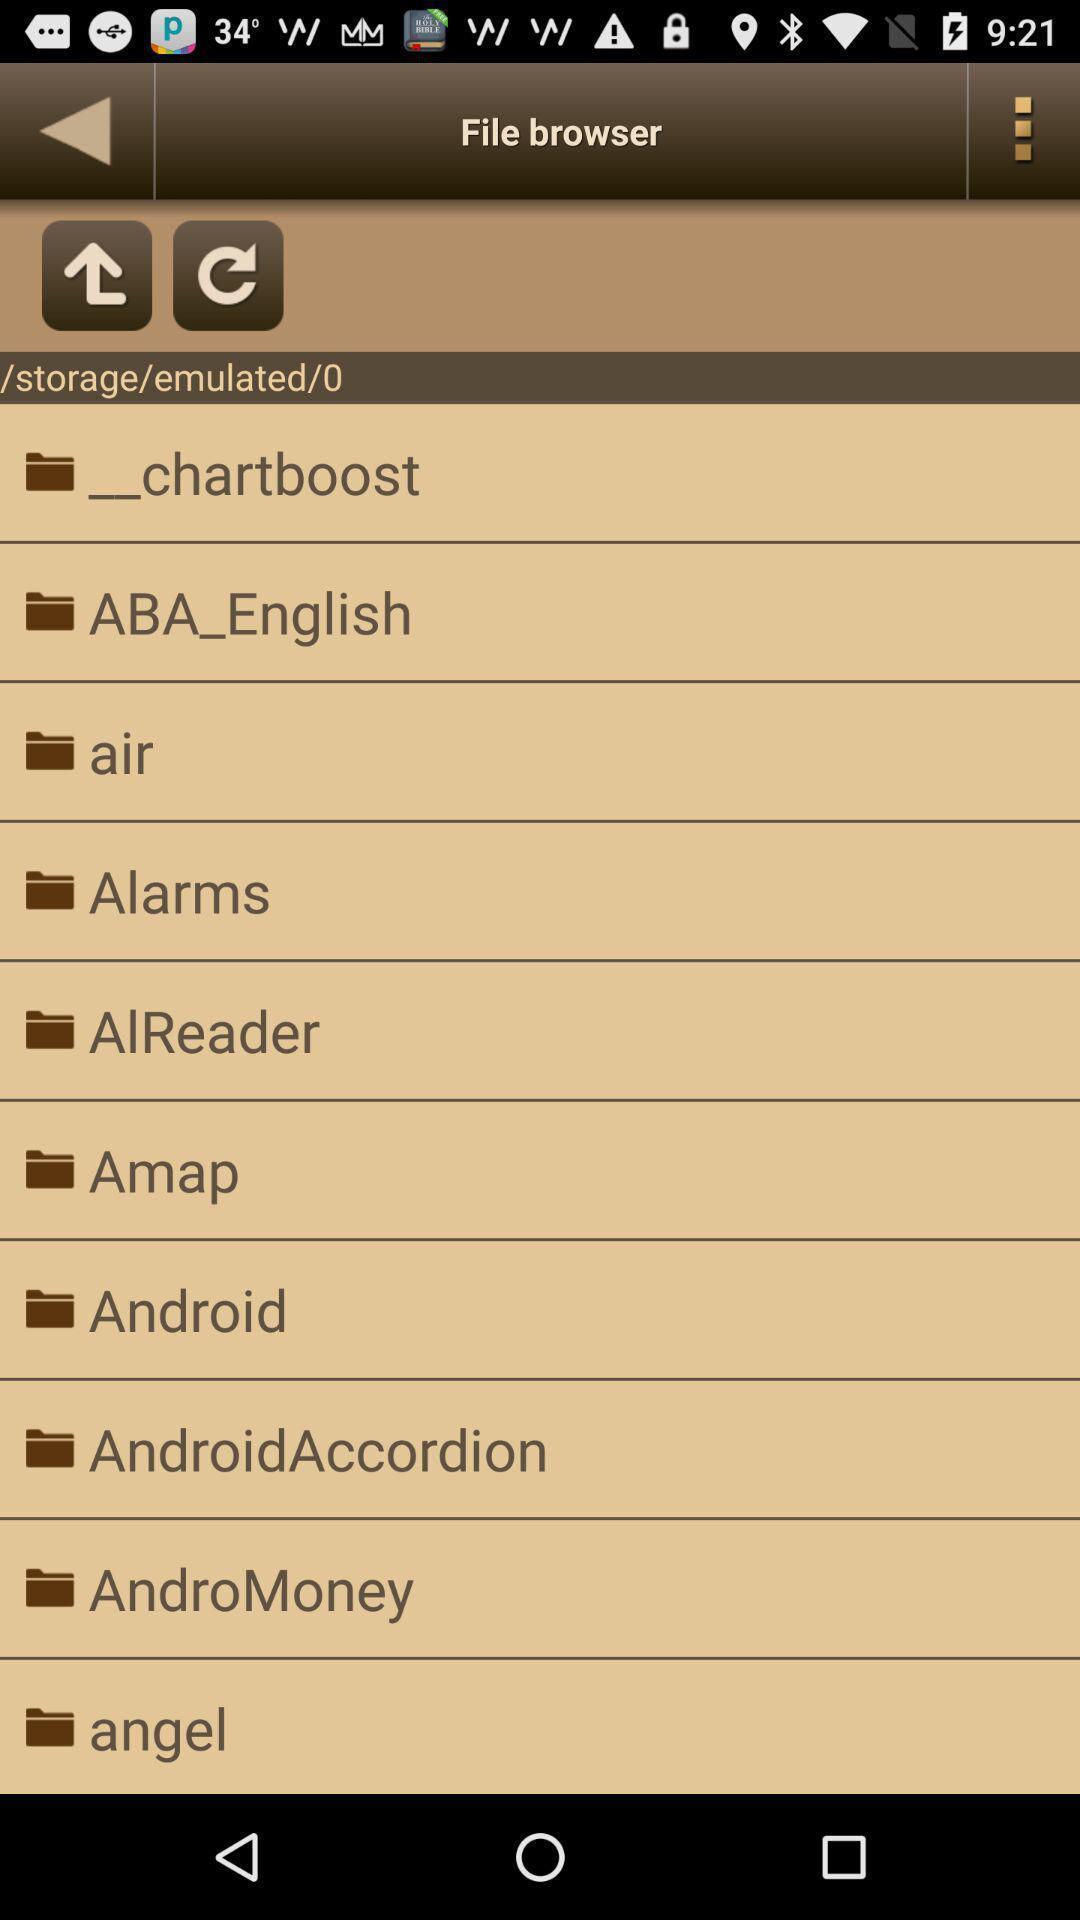Give me a narrative description of this picture. Screen displaying online books reading app. 